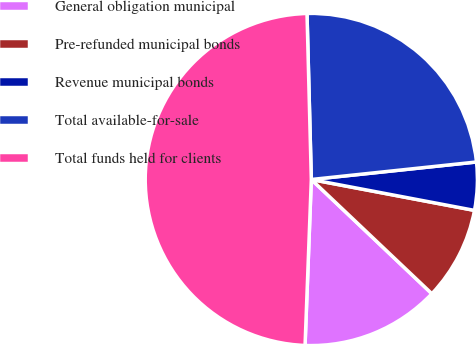Convert chart. <chart><loc_0><loc_0><loc_500><loc_500><pie_chart><fcel>General obligation municipal<fcel>Pre-refunded municipal bonds<fcel>Revenue municipal bonds<fcel>Total available-for-sale<fcel>Total funds held for clients<nl><fcel>13.53%<fcel>9.09%<fcel>4.66%<fcel>23.73%<fcel>48.98%<nl></chart> 